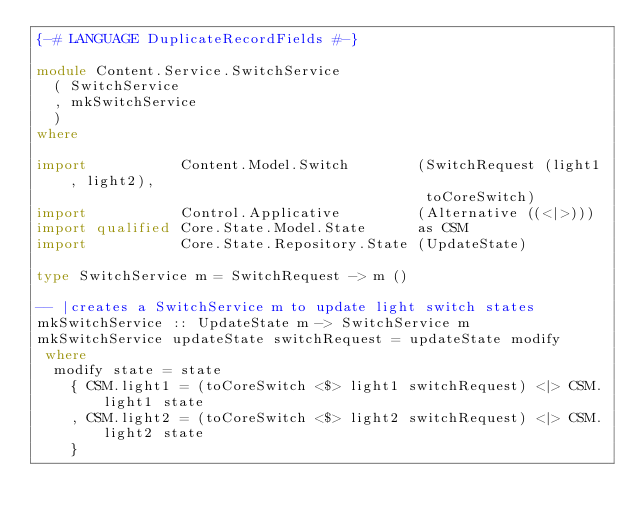Convert code to text. <code><loc_0><loc_0><loc_500><loc_500><_Haskell_>{-# LANGUAGE DuplicateRecordFields #-}

module Content.Service.SwitchService
  ( SwitchService
  , mkSwitchService
  )
where

import           Content.Model.Switch        (SwitchRequest (light1, light2),
                                              toCoreSwitch)
import           Control.Applicative         (Alternative ((<|>)))
import qualified Core.State.Model.State      as CSM
import           Core.State.Repository.State (UpdateState)

type SwitchService m = SwitchRequest -> m ()

-- |creates a SwitchService m to update light switch states
mkSwitchService :: UpdateState m -> SwitchService m
mkSwitchService updateState switchRequest = updateState modify
 where
  modify state = state
    { CSM.light1 = (toCoreSwitch <$> light1 switchRequest) <|> CSM.light1 state
    , CSM.light2 = (toCoreSwitch <$> light2 switchRequest) <|> CSM.light2 state
    }
</code> 